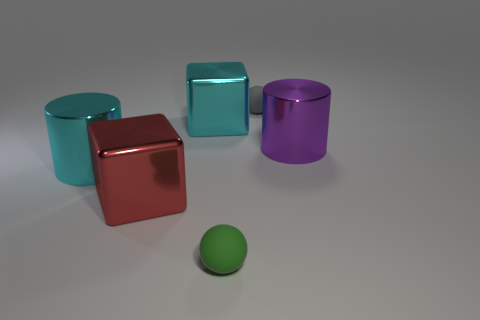Add 3 cyan objects. How many objects exist? 9 Subtract all spheres. How many objects are left? 4 Subtract 1 green balls. How many objects are left? 5 Subtract all large purple cubes. Subtract all matte things. How many objects are left? 4 Add 4 big red objects. How many big red objects are left? 5 Add 1 large blue rubber cubes. How many large blue rubber cubes exist? 1 